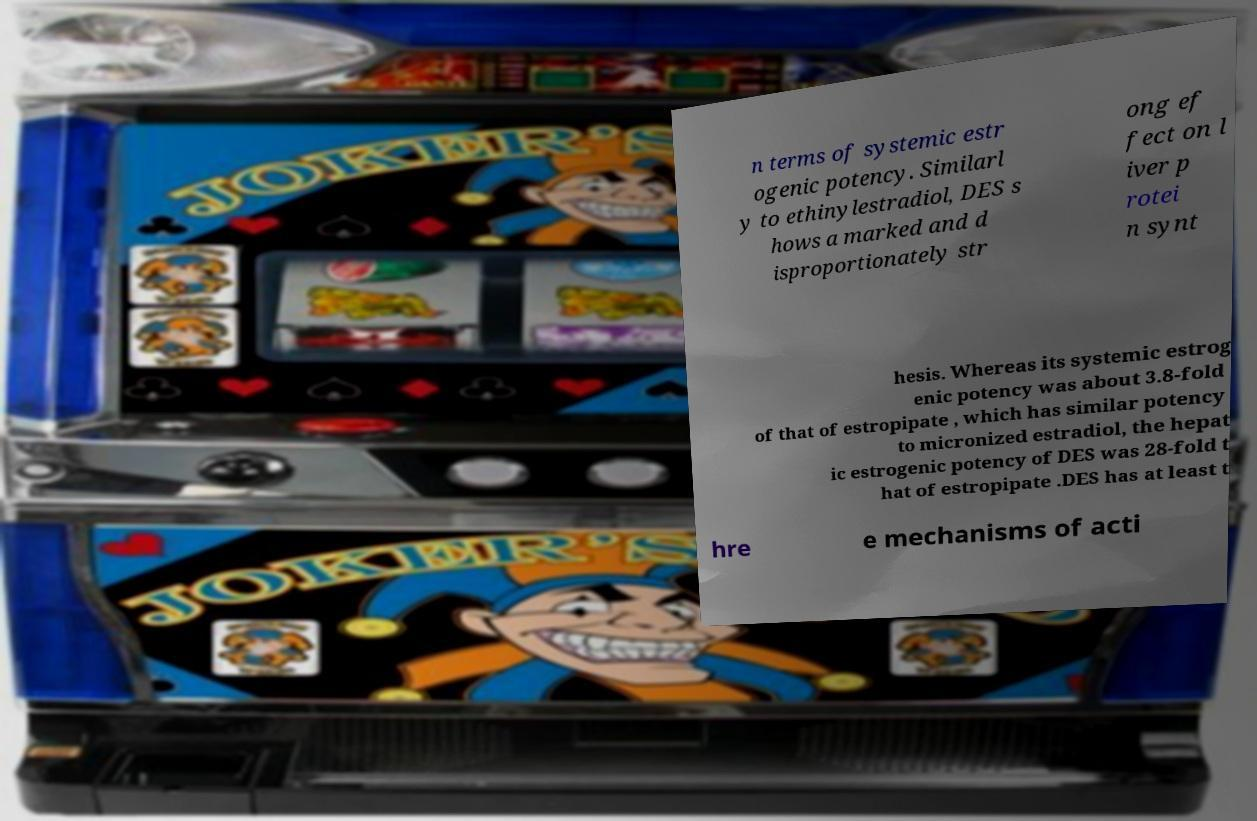There's text embedded in this image that I need extracted. Can you transcribe it verbatim? n terms of systemic estr ogenic potency. Similarl y to ethinylestradiol, DES s hows a marked and d isproportionately str ong ef fect on l iver p rotei n synt hesis. Whereas its systemic estrog enic potency was about 3.8-fold of that of estropipate , which has similar potency to micronized estradiol, the hepat ic estrogenic potency of DES was 28-fold t hat of estropipate .DES has at least t hre e mechanisms of acti 